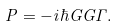<formula> <loc_0><loc_0><loc_500><loc_500>P = - i \hbar { G } G \Gamma .</formula> 